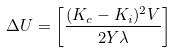Convert formula to latex. <formula><loc_0><loc_0><loc_500><loc_500>\Delta U = \left [ \frac { ( K _ { c } - K _ { i } ) ^ { 2 } V } { 2 Y \lambda } \right ]</formula> 